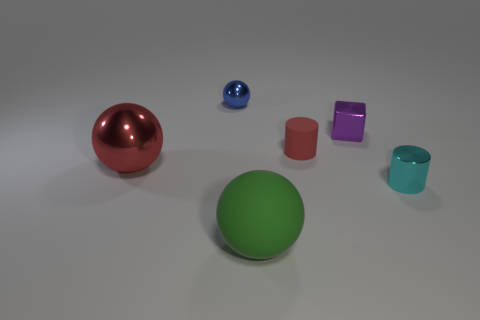Is there anything else that is the same shape as the small purple metallic thing?
Your answer should be compact. No. Does the cyan thing have the same material as the big object that is behind the green matte object?
Ensure brevity in your answer.  Yes. Is there a blue sphere that is to the left of the sphere behind the red matte object?
Your answer should be compact. No. What color is the shiny object that is both in front of the rubber cylinder and to the left of the cyan metallic cylinder?
Provide a succinct answer. Red. How big is the green sphere?
Offer a terse response. Large. How many purple blocks have the same size as the blue object?
Make the answer very short. 1. Do the tiny object that is left of the green matte thing and the tiny red thing that is in front of the tiny purple shiny block have the same material?
Your answer should be compact. No. The cylinder in front of the matte thing behind the green thing is made of what material?
Provide a succinct answer. Metal. What is the material of the small cylinder right of the small shiny block?
Your answer should be very brief. Metal. How many purple metal objects have the same shape as the large matte object?
Provide a succinct answer. 0. 